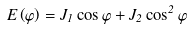<formula> <loc_0><loc_0><loc_500><loc_500>E \left ( \varphi \right ) = J _ { 1 } \cos \varphi + J _ { 2 } \cos ^ { 2 } \varphi</formula> 